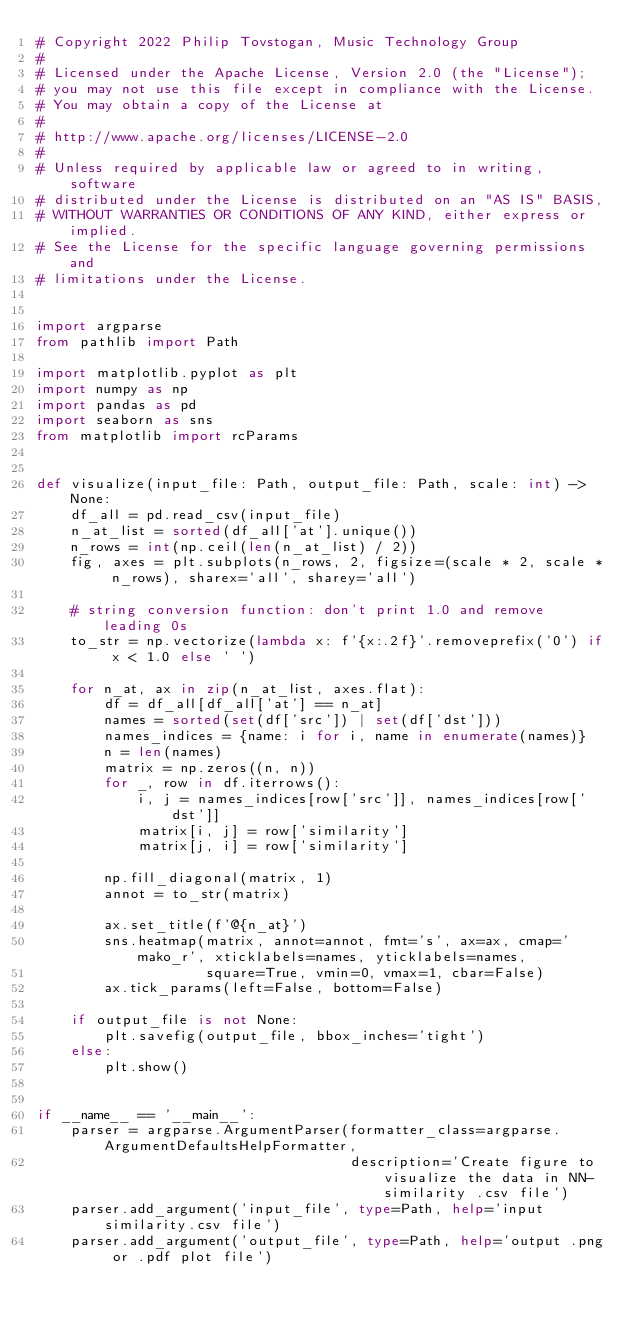Convert code to text. <code><loc_0><loc_0><loc_500><loc_500><_Python_># Copyright 2022 Philip Tovstogan, Music Technology Group
#
# Licensed under the Apache License, Version 2.0 (the "License");
# you may not use this file except in compliance with the License.
# You may obtain a copy of the License at
#
# http://www.apache.org/licenses/LICENSE-2.0
#
# Unless required by applicable law or agreed to in writing, software
# distributed under the License is distributed on an "AS IS" BASIS,
# WITHOUT WARRANTIES OR CONDITIONS OF ANY KIND, either express or implied.
# See the License for the specific language governing permissions and
# limitations under the License.


import argparse
from pathlib import Path

import matplotlib.pyplot as plt
import numpy as np
import pandas as pd
import seaborn as sns
from matplotlib import rcParams


def visualize(input_file: Path, output_file: Path, scale: int) -> None:
    df_all = pd.read_csv(input_file)
    n_at_list = sorted(df_all['at'].unique())
    n_rows = int(np.ceil(len(n_at_list) / 2))
    fig, axes = plt.subplots(n_rows, 2, figsize=(scale * 2, scale * n_rows), sharex='all', sharey='all')

    # string conversion function: don't print 1.0 and remove leading 0s
    to_str = np.vectorize(lambda x: f'{x:.2f}'.removeprefix('0') if x < 1.0 else ' ')

    for n_at, ax in zip(n_at_list, axes.flat):
        df = df_all[df_all['at'] == n_at]
        names = sorted(set(df['src']) | set(df['dst']))
        names_indices = {name: i for i, name in enumerate(names)}
        n = len(names)
        matrix = np.zeros((n, n))
        for _, row in df.iterrows():
            i, j = names_indices[row['src']], names_indices[row['dst']]
            matrix[i, j] = row['similarity']
            matrix[j, i] = row['similarity']

        np.fill_diagonal(matrix, 1)
        annot = to_str(matrix)

        ax.set_title(f'@{n_at}')
        sns.heatmap(matrix, annot=annot, fmt='s', ax=ax, cmap='mako_r', xticklabels=names, yticklabels=names,
                    square=True, vmin=0, vmax=1, cbar=False)
        ax.tick_params(left=False, bottom=False)

    if output_file is not None:
        plt.savefig(output_file, bbox_inches='tight')
    else:
        plt.show()


if __name__ == '__main__':
    parser = argparse.ArgumentParser(formatter_class=argparse.ArgumentDefaultsHelpFormatter,
                                     description='Create figure to visualize the data in NN-similarity .csv file')
    parser.add_argument('input_file', type=Path, help='input similarity.csv file')
    parser.add_argument('output_file', type=Path, help='output .png or .pdf plot file')</code> 